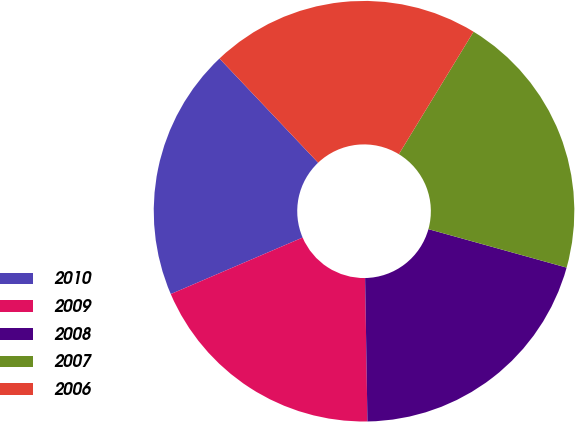Convert chart to OTSL. <chart><loc_0><loc_0><loc_500><loc_500><pie_chart><fcel>2010<fcel>2009<fcel>2008<fcel>2007<fcel>2006<nl><fcel>19.38%<fcel>18.81%<fcel>20.42%<fcel>20.6%<fcel>20.78%<nl></chart> 